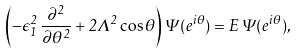Convert formula to latex. <formula><loc_0><loc_0><loc_500><loc_500>\left ( - \epsilon _ { 1 } ^ { 2 } \, \frac { \partial ^ { 2 } } { \partial \theta ^ { 2 } } + 2 \Lambda ^ { 2 } \cos \theta \right ) \Psi ( e ^ { i \theta } ) = E \, \Psi ( e ^ { i \theta } ) ,</formula> 